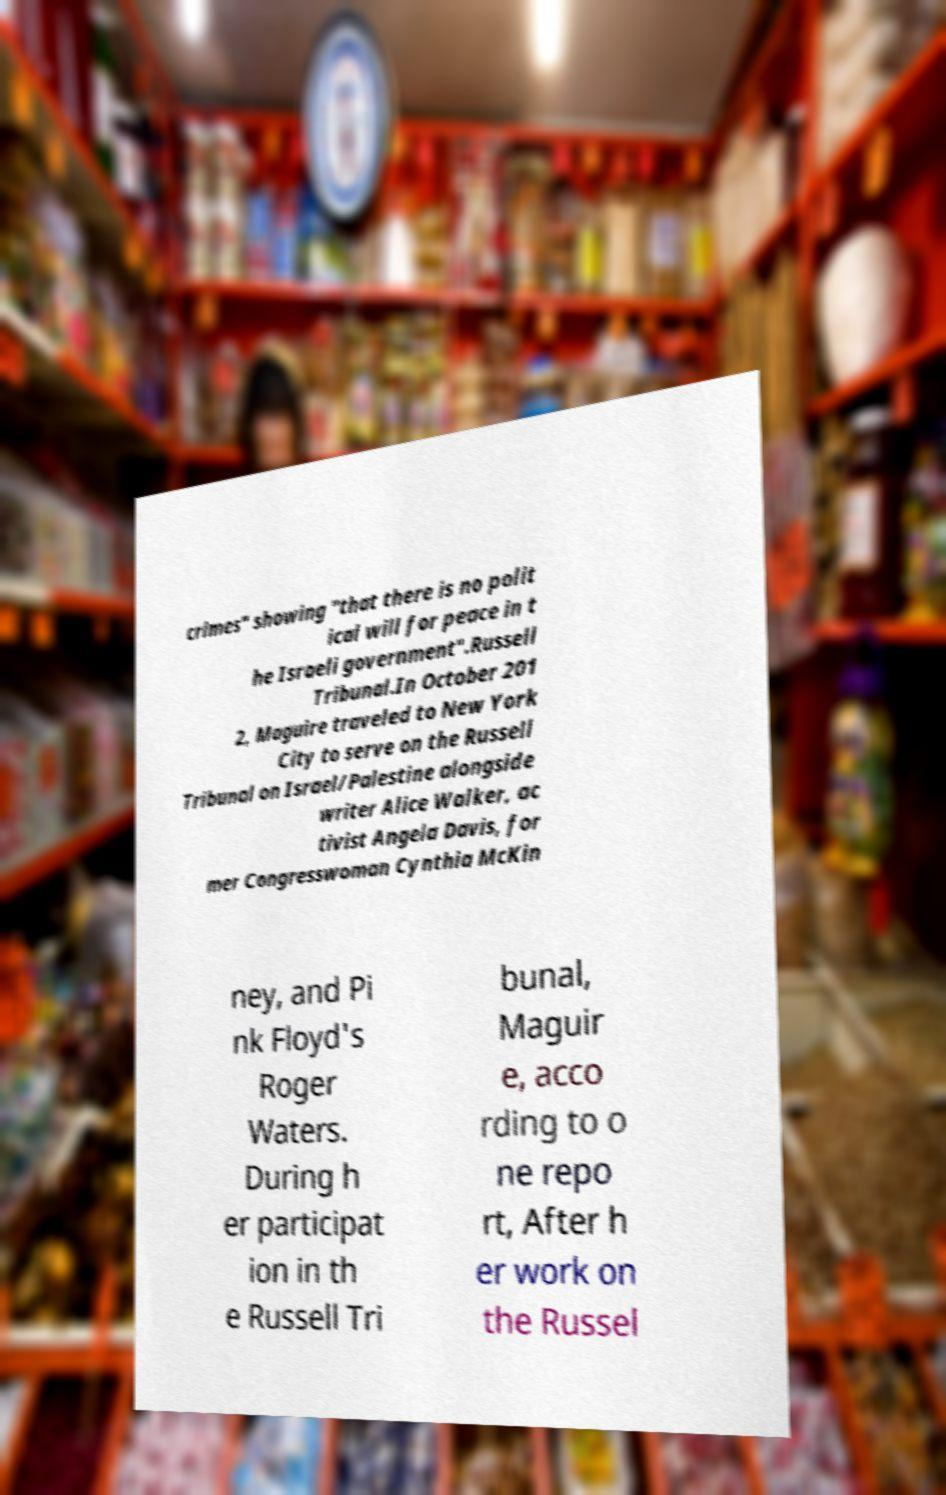What messages or text are displayed in this image? I need them in a readable, typed format. crimes" showing "that there is no polit ical will for peace in t he Israeli government".Russell Tribunal.In October 201 2, Maguire traveled to New York City to serve on the Russell Tribunal on Israel/Palestine alongside writer Alice Walker, ac tivist Angela Davis, for mer Congresswoman Cynthia McKin ney, and Pi nk Floyd's Roger Waters. During h er participat ion in th e Russell Tri bunal, Maguir e, acco rding to o ne repo rt, After h er work on the Russel 